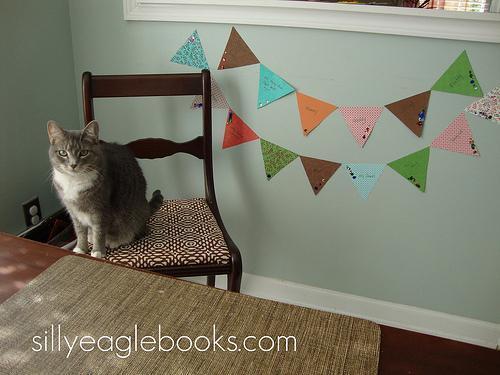How many animals are in the picture?
Give a very brief answer. 1. How many cats?
Give a very brief answer. 1. How many electrical outlets?
Give a very brief answer. 1. 